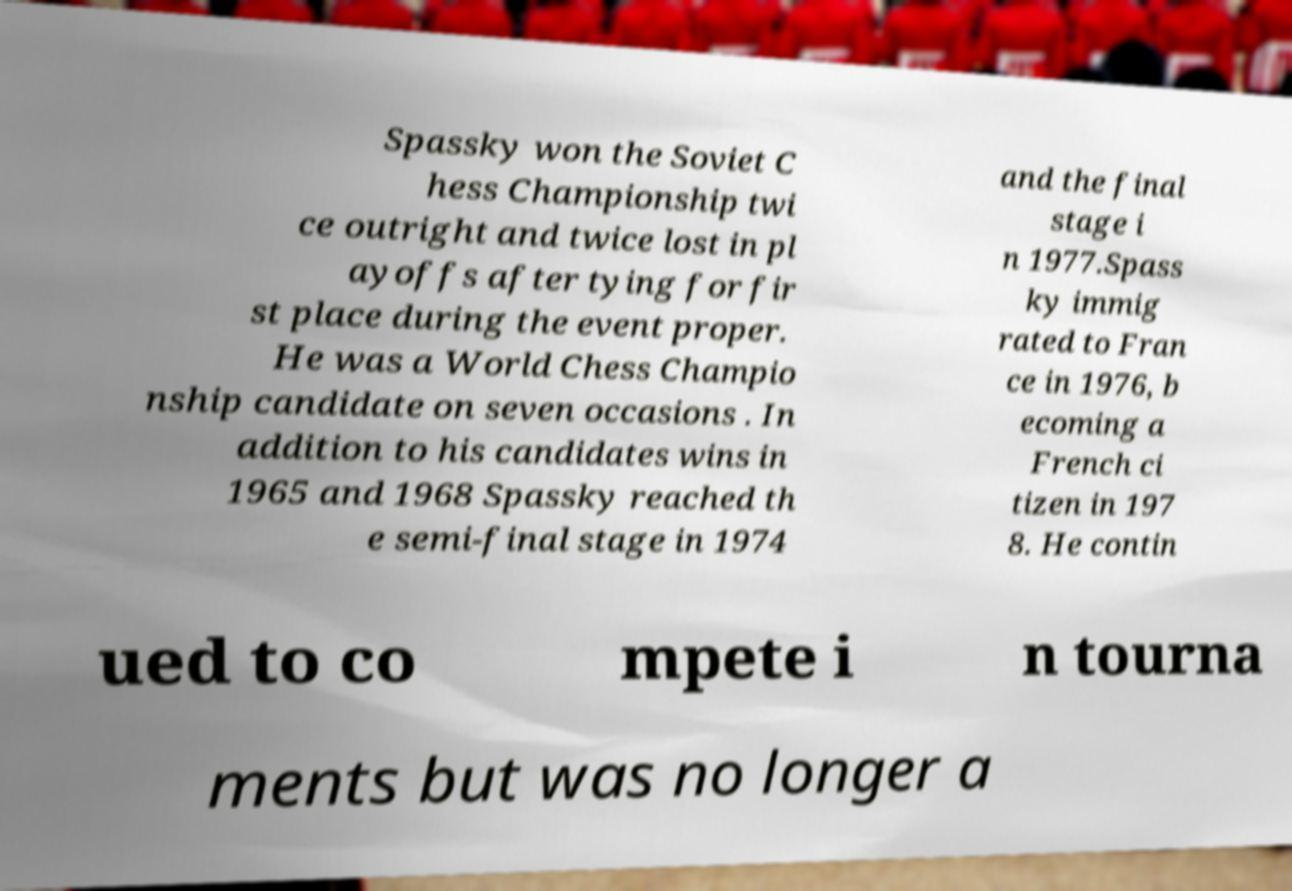Please identify and transcribe the text found in this image. Spassky won the Soviet C hess Championship twi ce outright and twice lost in pl ayoffs after tying for fir st place during the event proper. He was a World Chess Champio nship candidate on seven occasions . In addition to his candidates wins in 1965 and 1968 Spassky reached th e semi-final stage in 1974 and the final stage i n 1977.Spass ky immig rated to Fran ce in 1976, b ecoming a French ci tizen in 197 8. He contin ued to co mpete i n tourna ments but was no longer a 